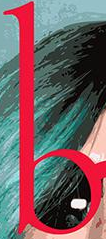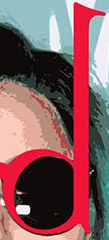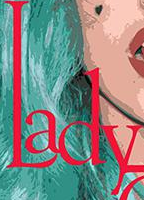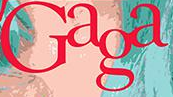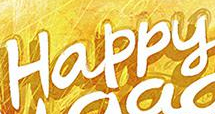What words are shown in these images in order, separated by a semicolon? b; d; Lady; Gaga; Happy 